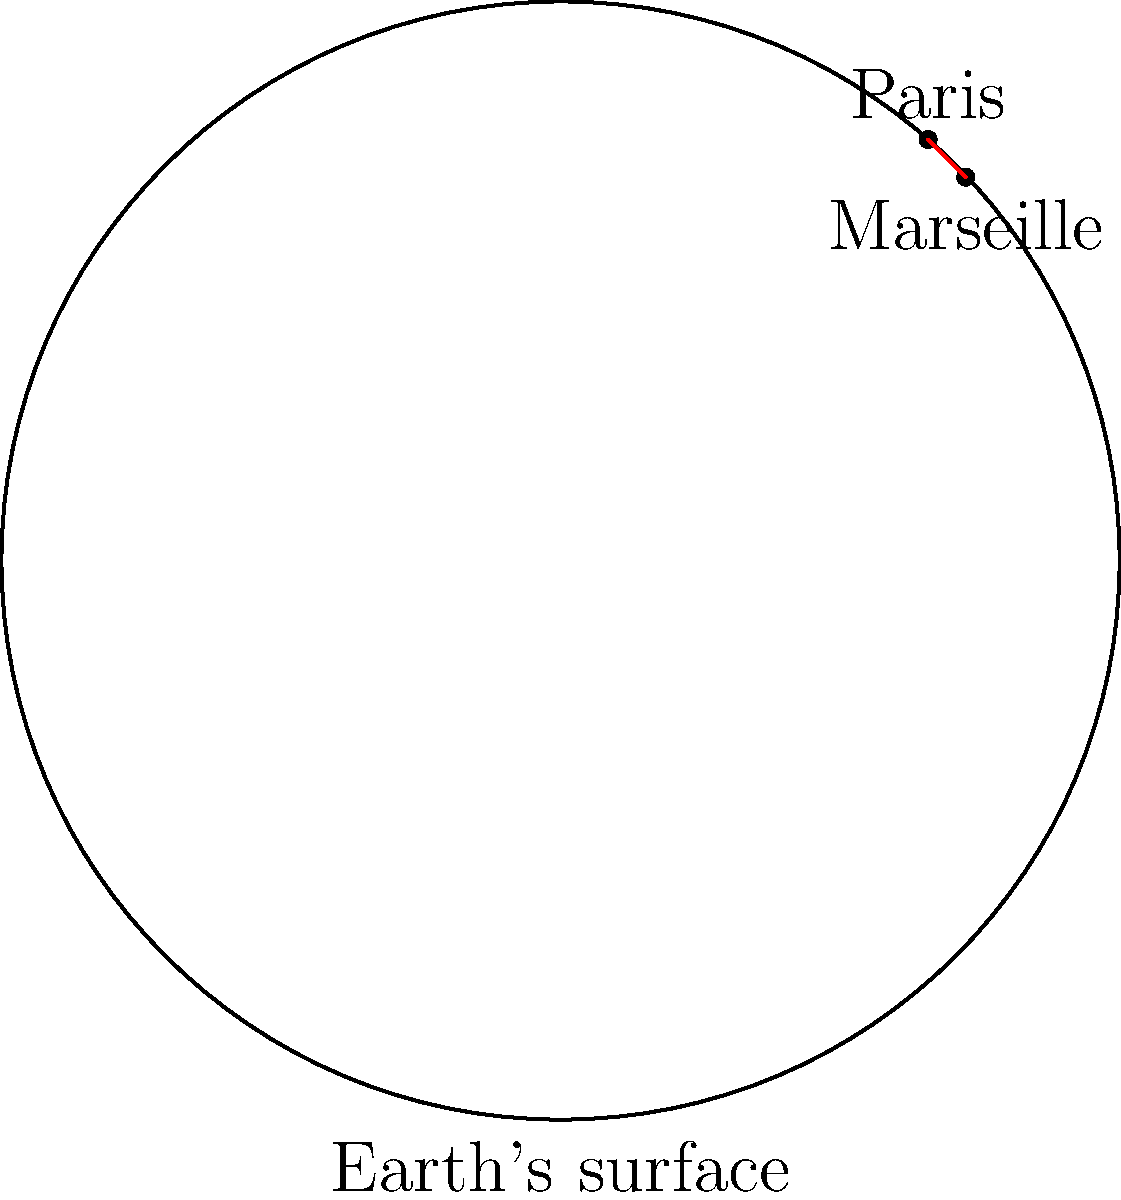As a culinary enthusiast exploring French cuisine, you're planning a trip from Paris to Marseille to taste the famous bouillabaisse. Given that Paris is located at coordinates (48.8566°N, 2.3522°E) and Marseille at (43.2965°N, 5.3698°E), calculate the shortest distance between these two cities on Earth's surface. Assume the Earth is a perfect sphere with a radius of 6,371 km. Round your answer to the nearest kilometer. To solve this problem, we'll use the Haversine formula, which calculates the great-circle distance between two points on a sphere given their latitudes and longitudes.

Step 1: Convert the latitudes and longitudes from degrees to radians:
$$\begin{align*}
\text{lat}_1 &= 48.8566° \times \frac{\pi}{180} = 0.8527 \text{ rad} \\
\text{lon}_1 &= 2.3522° \times \frac{\pi}{180} = 0.0411 \text{ rad} \\
\text{lat}_2 &= 43.2965° \times \frac{\pi}{180} = 0.7558 \text{ rad} \\
\text{lon}_2 &= 5.3698° \times \frac{\pi}{180} = 0.0937 \text{ rad}
\end{align*}$$

Step 2: Calculate the differences in latitude and longitude:
$$\begin{align*}
\Delta\text{lat} &= \text{lat}_2 - \text{lat}_1 = 0.7558 - 0.8527 = -0.0969 \text{ rad} \\
\Delta\text{lon} &= \text{lon}_2 - \text{lon}_1 = 0.0937 - 0.0411 = 0.0526 \text{ rad}
\end{align*}$$

Step 3: Apply the Haversine formula:
$$a = \sin^2(\frac{\Delta\text{lat}}{2}) + \cos(\text{lat}_1) \cos(\text{lat}_2) \sin^2(\frac{\Delta\text{lon}}{2})$$

$$a = \sin^2(-0.04845) + \cos(0.8527) \cos(0.7558) \sin^2(0.0263)$$
$$a = 0.002345 + 0.651917 \times 0.000691 = 0.002793$$

Step 4: Calculate the central angle:
$$c = 2 \times \arctan2(\sqrt{a}, \sqrt{1-a})$$
$$c = 2 \times \arctan2(\sqrt{0.002793}, \sqrt{1-0.002793}) = 0.1055 \text{ rad}$$

Step 5: Calculate the distance:
$$d = R \times c = 6371 \times 0.1055 = 671.96 \text{ km}$$

Step 6: Round to the nearest kilometer:
$$d \approx 672 \text{ km}$$
Answer: 672 km 